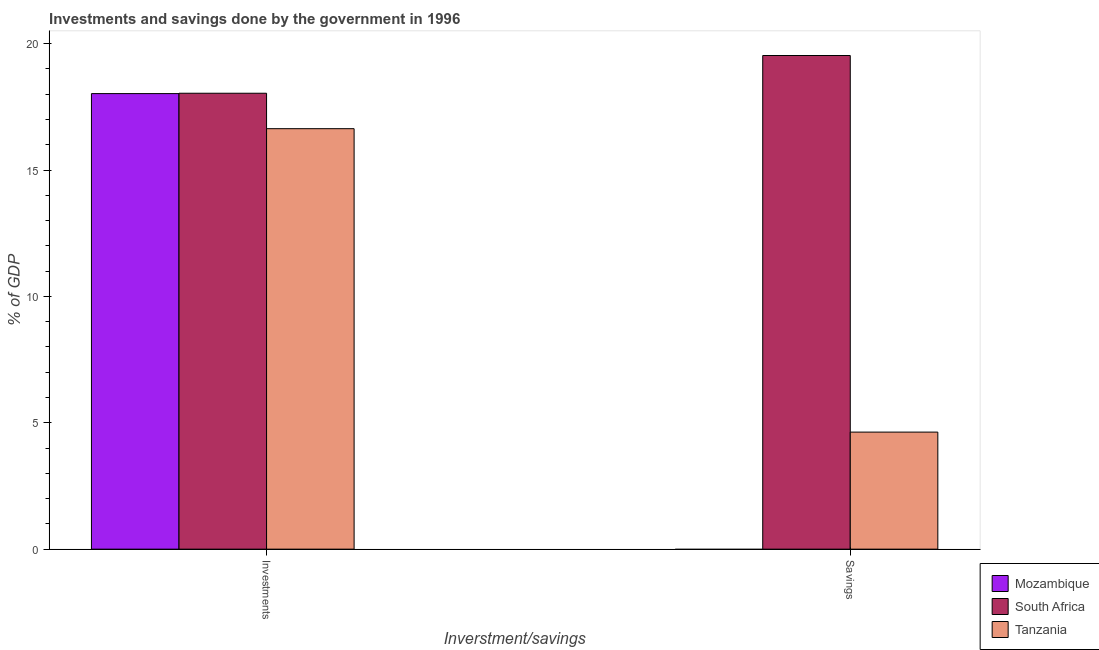Are the number of bars per tick equal to the number of legend labels?
Your response must be concise. No. How many bars are there on the 1st tick from the left?
Your answer should be very brief. 3. How many bars are there on the 2nd tick from the right?
Make the answer very short. 3. What is the label of the 1st group of bars from the left?
Offer a very short reply. Investments. What is the savings of government in Mozambique?
Your answer should be very brief. 0. Across all countries, what is the maximum investments of government?
Provide a short and direct response. 18.04. Across all countries, what is the minimum savings of government?
Provide a succinct answer. 0. In which country was the investments of government maximum?
Provide a short and direct response. South Africa. What is the total savings of government in the graph?
Provide a succinct answer. 24.16. What is the difference between the investments of government in South Africa and that in Tanzania?
Offer a terse response. 1.4. What is the difference between the savings of government in Mozambique and the investments of government in Tanzania?
Your answer should be compact. -16.64. What is the average savings of government per country?
Offer a terse response. 8.05. What is the difference between the savings of government and investments of government in Tanzania?
Keep it short and to the point. -12.01. In how many countries, is the savings of government greater than 3 %?
Offer a terse response. 2. What is the ratio of the investments of government in Tanzania to that in Mozambique?
Your answer should be compact. 0.92. Is the investments of government in Mozambique less than that in South Africa?
Your response must be concise. Yes. In how many countries, is the investments of government greater than the average investments of government taken over all countries?
Your answer should be compact. 2. How many bars are there?
Provide a short and direct response. 5. How many countries are there in the graph?
Keep it short and to the point. 3. What is the difference between two consecutive major ticks on the Y-axis?
Your response must be concise. 5. Are the values on the major ticks of Y-axis written in scientific E-notation?
Your answer should be very brief. No. Does the graph contain any zero values?
Make the answer very short. Yes. How are the legend labels stacked?
Give a very brief answer. Vertical. What is the title of the graph?
Offer a terse response. Investments and savings done by the government in 1996. What is the label or title of the X-axis?
Keep it short and to the point. Inverstment/savings. What is the label or title of the Y-axis?
Provide a succinct answer. % of GDP. What is the % of GDP of Mozambique in Investments?
Offer a terse response. 18.03. What is the % of GDP of South Africa in Investments?
Offer a very short reply. 18.04. What is the % of GDP in Tanzania in Investments?
Your answer should be compact. 16.64. What is the % of GDP in South Africa in Savings?
Offer a very short reply. 19.53. What is the % of GDP in Tanzania in Savings?
Keep it short and to the point. 4.63. Across all Inverstment/savings, what is the maximum % of GDP of Mozambique?
Give a very brief answer. 18.03. Across all Inverstment/savings, what is the maximum % of GDP of South Africa?
Keep it short and to the point. 19.53. Across all Inverstment/savings, what is the maximum % of GDP in Tanzania?
Provide a succinct answer. 16.64. Across all Inverstment/savings, what is the minimum % of GDP in Mozambique?
Make the answer very short. 0. Across all Inverstment/savings, what is the minimum % of GDP of South Africa?
Offer a very short reply. 18.04. Across all Inverstment/savings, what is the minimum % of GDP in Tanzania?
Ensure brevity in your answer.  4.63. What is the total % of GDP of Mozambique in the graph?
Provide a succinct answer. 18.03. What is the total % of GDP of South Africa in the graph?
Your response must be concise. 37.57. What is the total % of GDP in Tanzania in the graph?
Make the answer very short. 21.27. What is the difference between the % of GDP in South Africa in Investments and that in Savings?
Offer a very short reply. -1.49. What is the difference between the % of GDP in Tanzania in Investments and that in Savings?
Your response must be concise. 12.01. What is the difference between the % of GDP of Mozambique in Investments and the % of GDP of South Africa in Savings?
Your answer should be very brief. -1.51. What is the difference between the % of GDP of Mozambique in Investments and the % of GDP of Tanzania in Savings?
Ensure brevity in your answer.  13.39. What is the difference between the % of GDP in South Africa in Investments and the % of GDP in Tanzania in Savings?
Offer a very short reply. 13.41. What is the average % of GDP in Mozambique per Inverstment/savings?
Your response must be concise. 9.01. What is the average % of GDP of South Africa per Inverstment/savings?
Your answer should be compact. 18.79. What is the average % of GDP of Tanzania per Inverstment/savings?
Your answer should be very brief. 10.63. What is the difference between the % of GDP in Mozambique and % of GDP in South Africa in Investments?
Keep it short and to the point. -0.01. What is the difference between the % of GDP of Mozambique and % of GDP of Tanzania in Investments?
Give a very brief answer. 1.39. What is the difference between the % of GDP of South Africa and % of GDP of Tanzania in Investments?
Your response must be concise. 1.4. What is the difference between the % of GDP in South Africa and % of GDP in Tanzania in Savings?
Your response must be concise. 14.9. What is the ratio of the % of GDP of South Africa in Investments to that in Savings?
Your response must be concise. 0.92. What is the ratio of the % of GDP in Tanzania in Investments to that in Savings?
Keep it short and to the point. 3.59. What is the difference between the highest and the second highest % of GDP in South Africa?
Offer a very short reply. 1.49. What is the difference between the highest and the second highest % of GDP in Tanzania?
Give a very brief answer. 12.01. What is the difference between the highest and the lowest % of GDP of Mozambique?
Keep it short and to the point. 18.03. What is the difference between the highest and the lowest % of GDP in South Africa?
Make the answer very short. 1.49. What is the difference between the highest and the lowest % of GDP of Tanzania?
Make the answer very short. 12.01. 